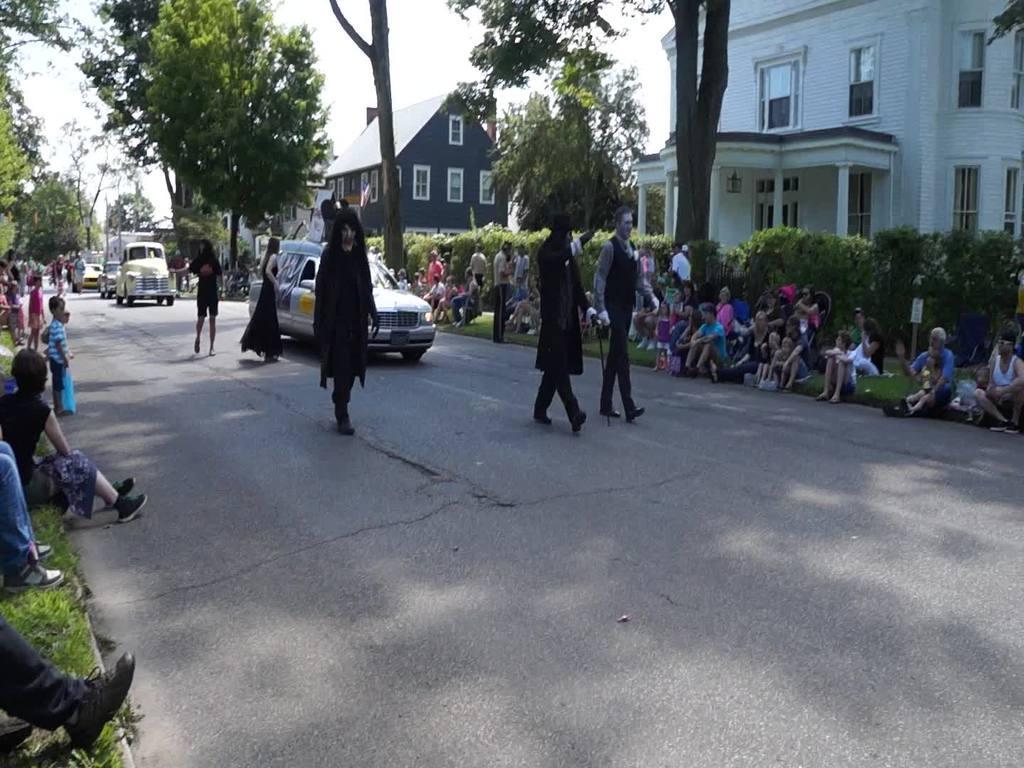Describe this image in one or two sentences. In this image, we can see vehicles on the road and there are many people and some of them are wearing costumes. In the background, there are trees, buildings and boards. At the top, there is sky. 